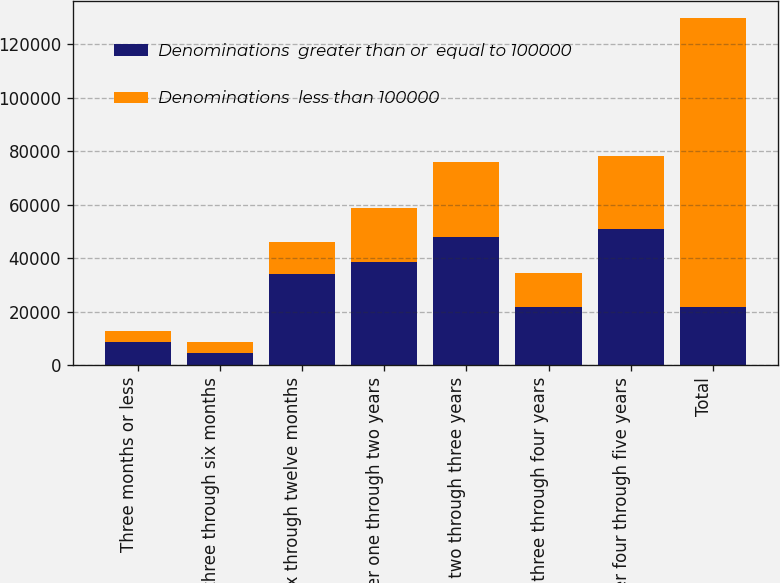Convert chart. <chart><loc_0><loc_0><loc_500><loc_500><stacked_bar_chart><ecel><fcel>Three months or less<fcel>Over three through six months<fcel>Over six through twelve months<fcel>Over one through two years<fcel>Over two through three years<fcel>Over three through four years<fcel>Over four through five years<fcel>Total<nl><fcel>Denominations  greater than or  equal to 100000<fcel>8704<fcel>4692<fcel>34005<fcel>38713<fcel>48082<fcel>21819<fcel>50805<fcel>21819<nl><fcel>Denominations  less than 100000<fcel>4132<fcel>3894<fcel>11865<fcel>20019<fcel>27847<fcel>12761<fcel>27347<fcel>107865<nl></chart> 